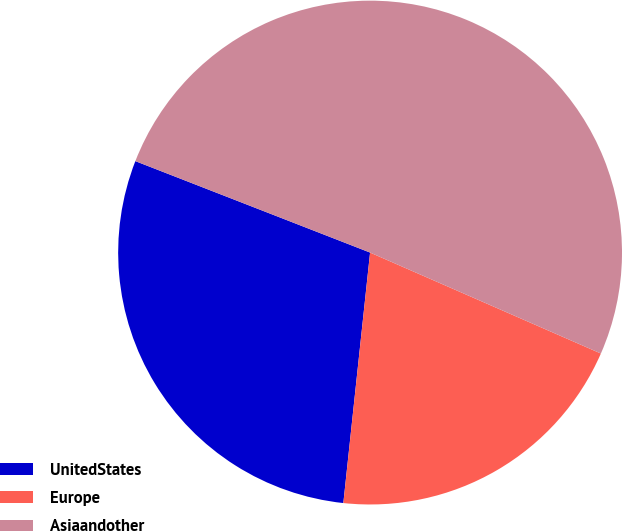Convert chart to OTSL. <chart><loc_0><loc_0><loc_500><loc_500><pie_chart><fcel>UnitedStates<fcel>Europe<fcel>Asiaandother<nl><fcel>29.22%<fcel>20.13%<fcel>50.65%<nl></chart> 